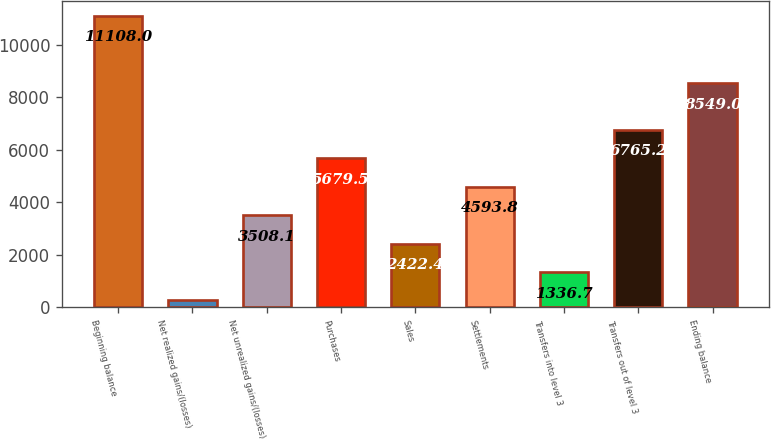Convert chart. <chart><loc_0><loc_0><loc_500><loc_500><bar_chart><fcel>Beginning balance<fcel>Net realized gains/(losses)<fcel>Net unrealized gains/(losses)<fcel>Purchases<fcel>Sales<fcel>Settlements<fcel>Transfers into level 3<fcel>Transfers out of level 3<fcel>Ending balance<nl><fcel>11108<fcel>251<fcel>3508.1<fcel>5679.5<fcel>2422.4<fcel>4593.8<fcel>1336.7<fcel>6765.2<fcel>8549<nl></chart> 